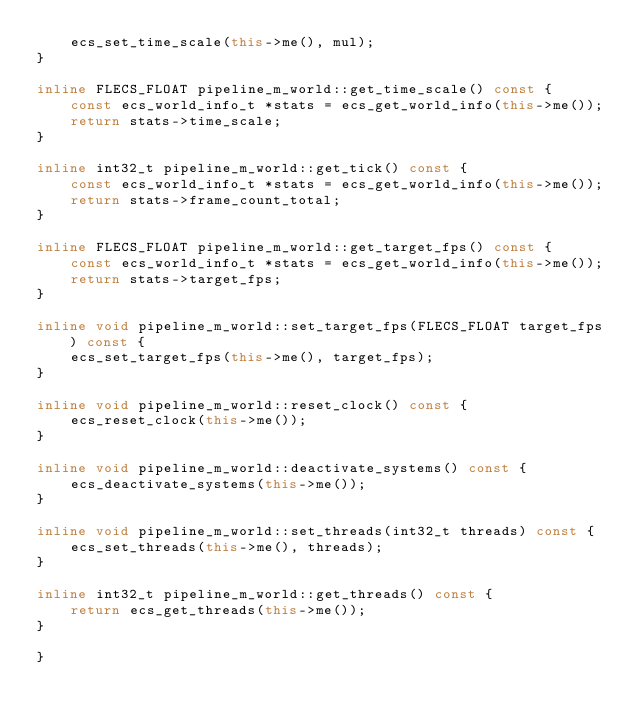<code> <loc_0><loc_0><loc_500><loc_500><_C++_>    ecs_set_time_scale(this->me(), mul);
}  

inline FLECS_FLOAT pipeline_m_world::get_time_scale() const {
    const ecs_world_info_t *stats = ecs_get_world_info(this->me());
    return stats->time_scale;
}

inline int32_t pipeline_m_world::get_tick() const {
    const ecs_world_info_t *stats = ecs_get_world_info(this->me());
    return stats->frame_count_total;
}

inline FLECS_FLOAT pipeline_m_world::get_target_fps() const {
    const ecs_world_info_t *stats = ecs_get_world_info(this->me());
    return stats->target_fps;
} 

inline void pipeline_m_world::set_target_fps(FLECS_FLOAT target_fps) const {
    ecs_set_target_fps(this->me(), target_fps);
}

inline void pipeline_m_world::reset_clock() const {
    ecs_reset_clock(this->me());
}

inline void pipeline_m_world::deactivate_systems() const {
    ecs_deactivate_systems(this->me());
}

inline void pipeline_m_world::set_threads(int32_t threads) const {
    ecs_set_threads(this->me(), threads);
}

inline int32_t pipeline_m_world::get_threads() const {
    return ecs_get_threads(this->me());
}

}
</code> 